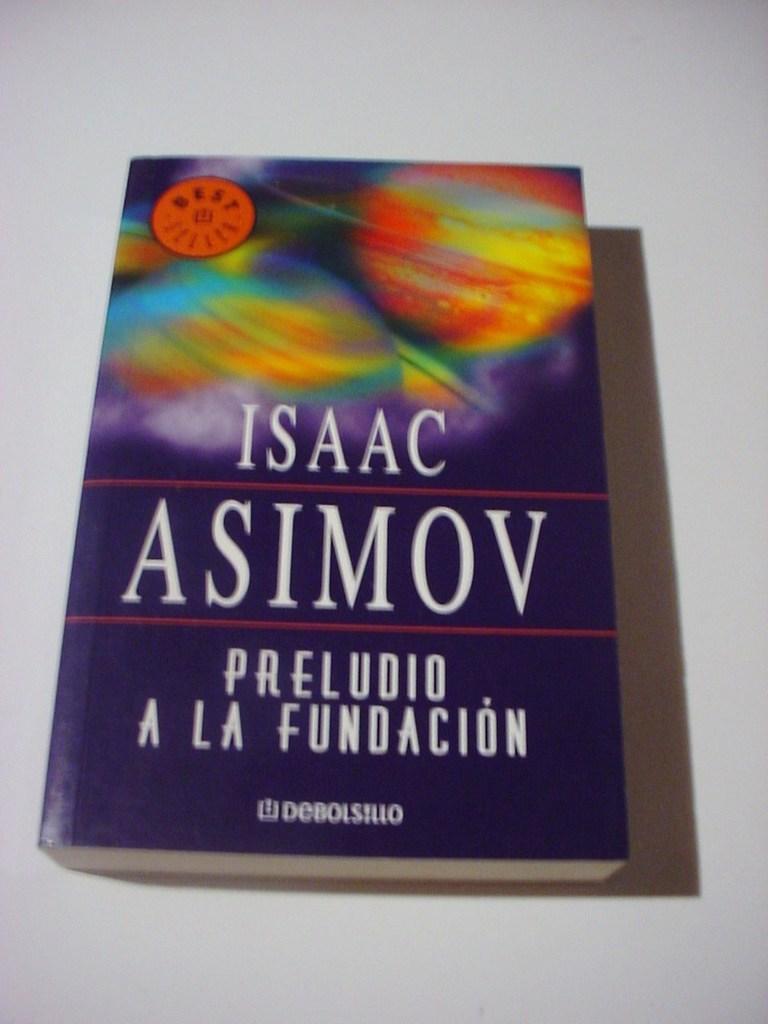Who is the author of this writing?
Offer a terse response. Isaac asimov. Does the sticker in the top left say "best"?
Give a very brief answer. Yes. 